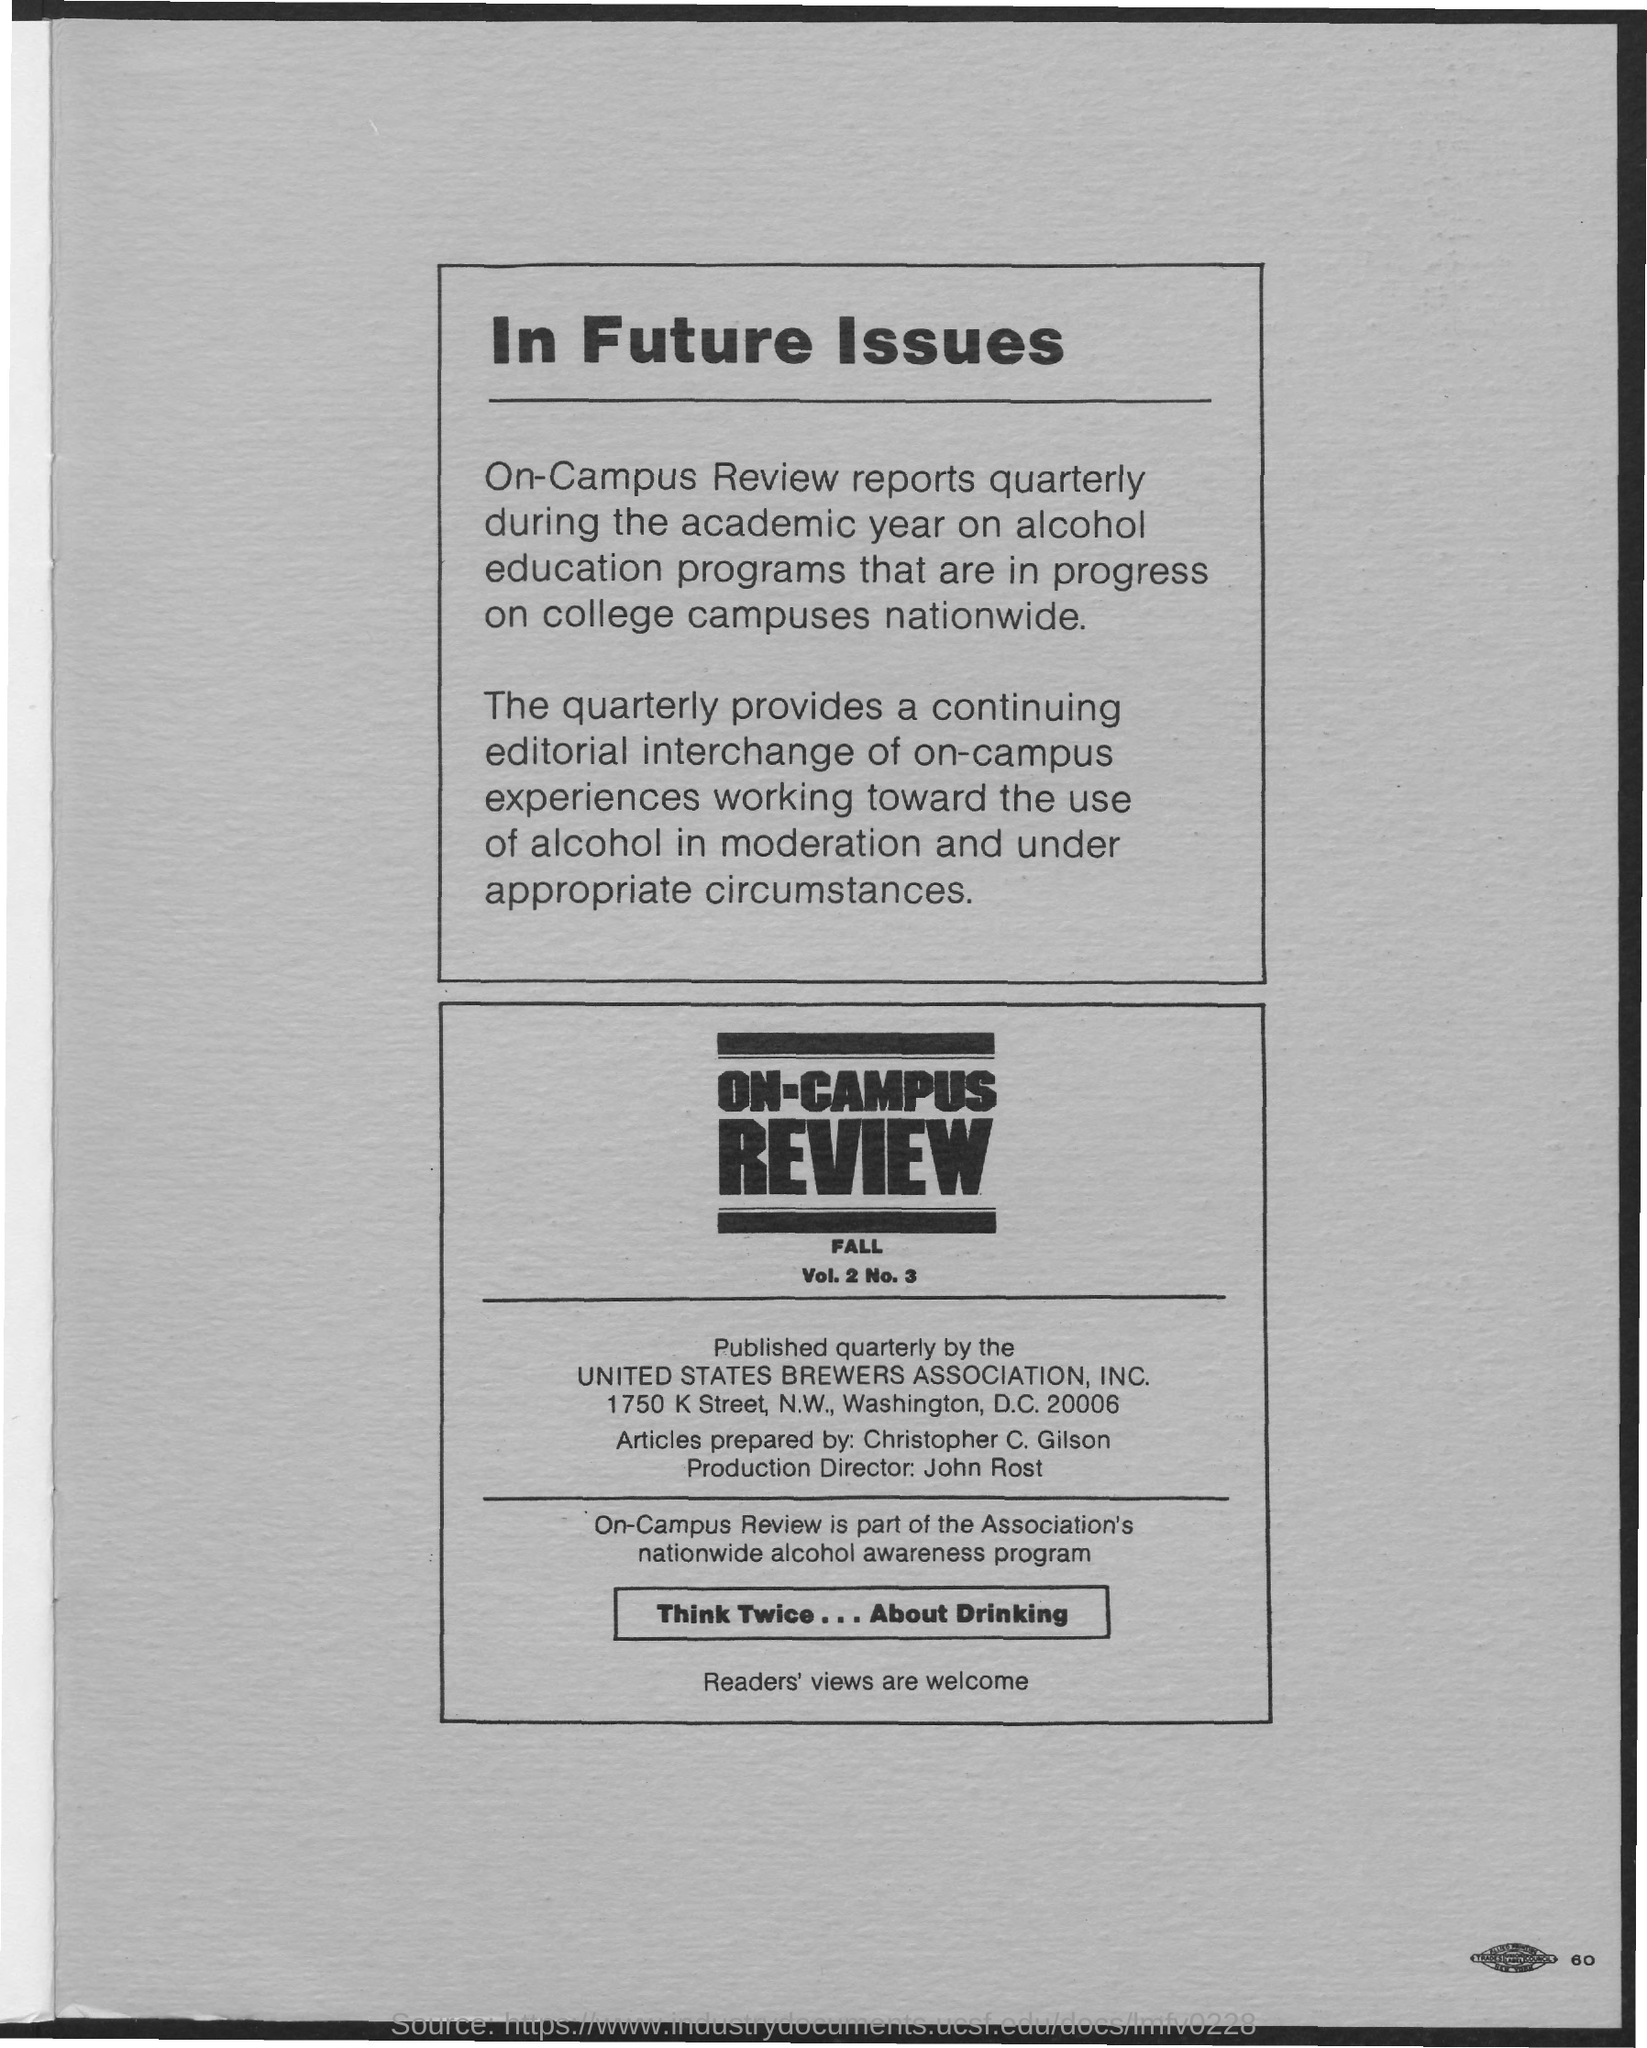On- Campus Review is published quarterly by?
Make the answer very short. United States Brewers Association, Inc. Who is the production director?
Offer a terse response. John Rost. Who prepares articles?
Offer a terse response. Christopher C. Gilson. What is the address of united states brewers association, inc.?
Provide a succinct answer. 1750 K street, N.W., Washington, D.C. 20006. 